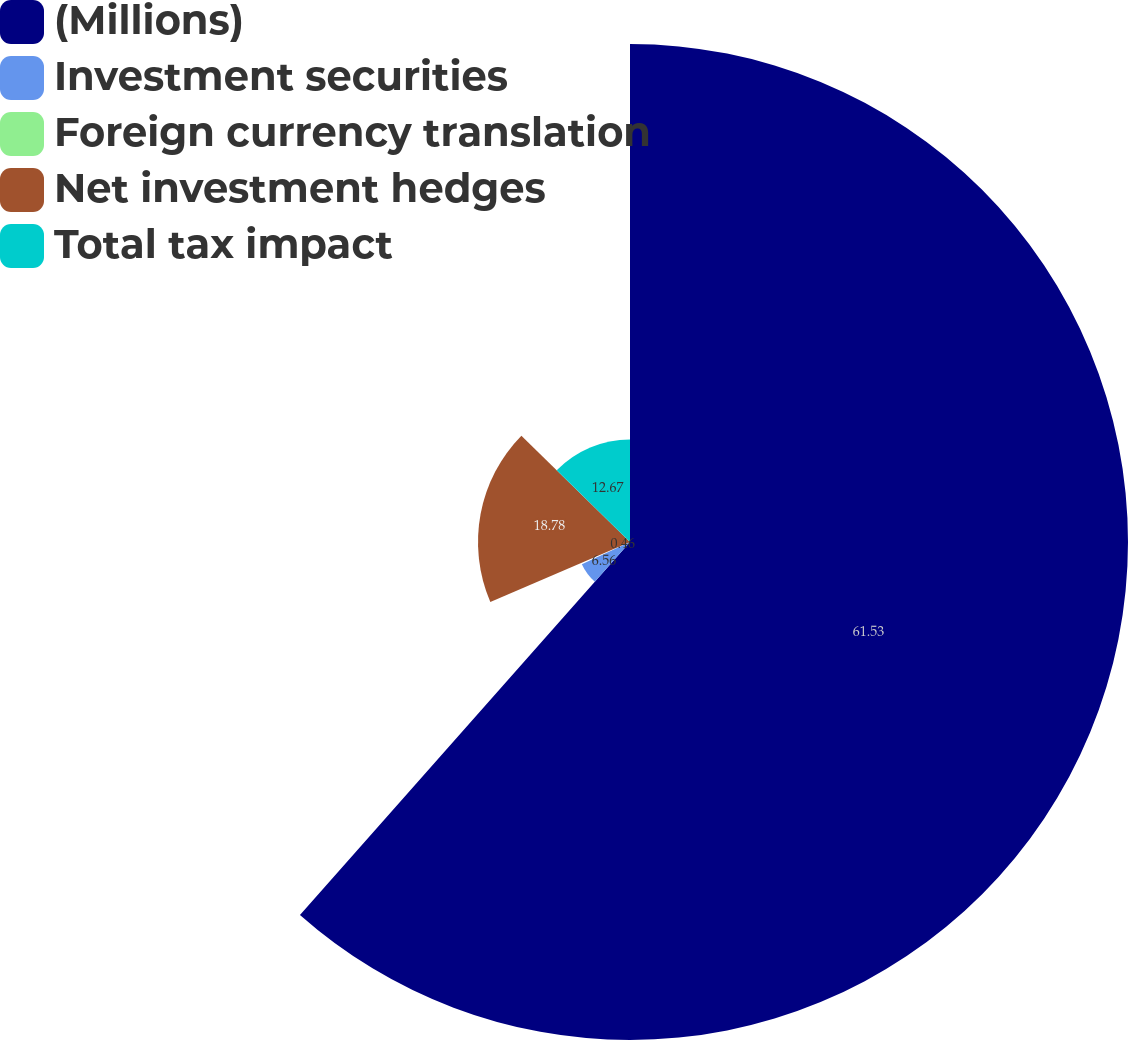<chart> <loc_0><loc_0><loc_500><loc_500><pie_chart><fcel>(Millions)<fcel>Investment securities<fcel>Foreign currency translation<fcel>Net investment hedges<fcel>Total tax impact<nl><fcel>61.53%<fcel>6.56%<fcel>0.46%<fcel>18.78%<fcel>12.67%<nl></chart> 